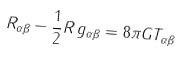Convert formula to latex. <formula><loc_0><loc_0><loc_500><loc_500>R _ { \alpha \beta } - \frac { 1 } { 2 } R \, g _ { \alpha \beta } = 8 \pi G T _ { \alpha \beta }</formula> 